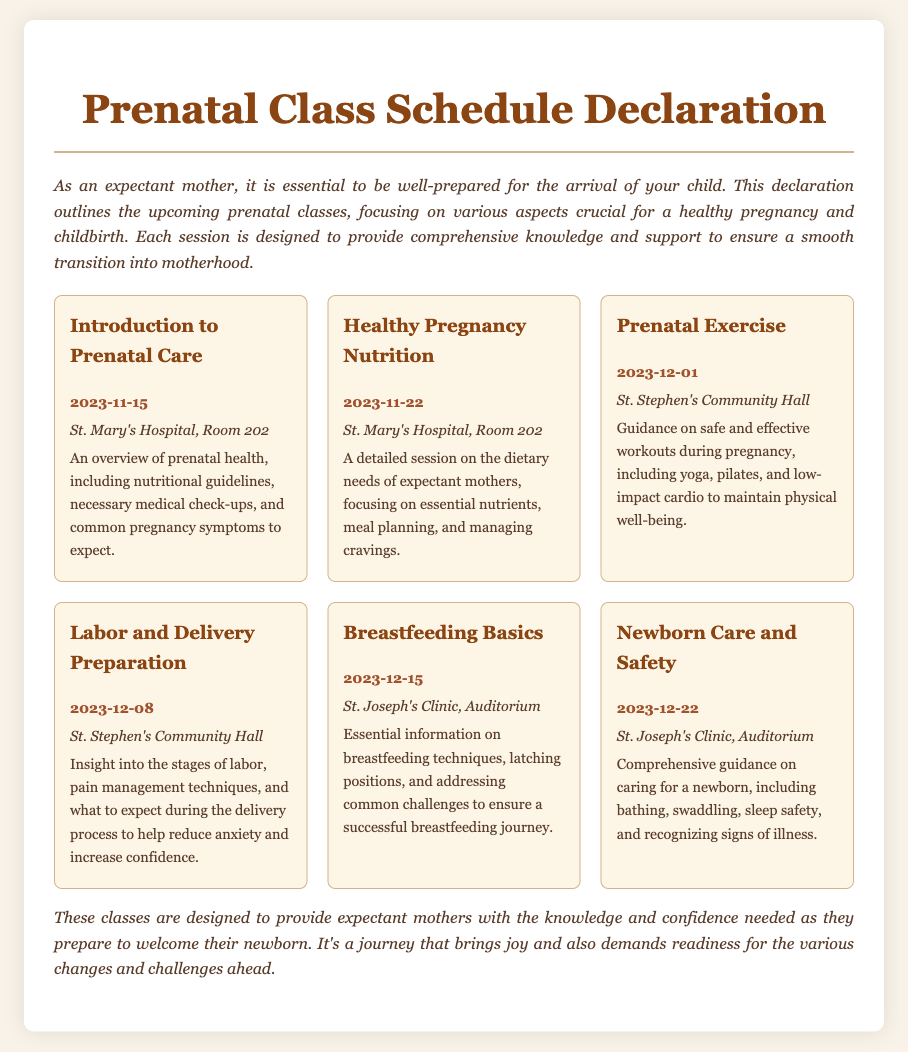What is the date of the Introduction to Prenatal Care class? The date for the Introduction to Prenatal Care class is listed in the document as November 15, 2023.
Answer: November 15, 2023 Where will the Healthy Pregnancy Nutrition class be held? The location for the Healthy Pregnancy Nutrition class is specified in the document as St. Mary's Hospital, Room 202.
Answer: St. Mary's Hospital, Room 202 How many topics are covered in the schedule? There are six topics listed in the schedule, each corresponding to a different class.
Answer: Six What is the main focus of the Labor and Delivery Preparation session? The document describes the Labor and Delivery Preparation class as providing insight into the stages of labor and pain management techniques.
Answer: Stages of labor and pain management techniques What session discusses breastfeeding techniques? The session that covers breastfeeding techniques is called Breastfeeding Basics, as noted in the schedule.
Answer: Breastfeeding Basics Which class is held at St. Joseph's Clinic, Auditorium? The classes listed in the document that are held at St. Joseph's Clinic, Auditorium are Breastfeeding Basics and Newborn Care and Safety.
Answer: Breastfeeding Basics and Newborn Care and Safety What is the focus of the Newborn Care and Safety class? The Newborn Care and Safety class focuses on caring for a newborn, including bathing and sleep safety, according to the document.
Answer: Caring for a newborn When is the last class of the schedule? The last class mentioned in the schedule is scheduled for December 22, 2023.
Answer: December 22, 2023 